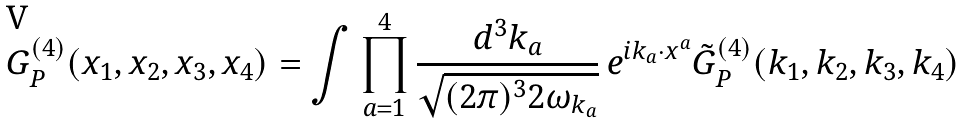<formula> <loc_0><loc_0><loc_500><loc_500>G ^ { ( 4 ) } _ { P } ( x _ { 1 } , x _ { 2 } , x _ { 3 } , x _ { 4 } ) = \int \prod _ { a = 1 } ^ { 4 } \frac { d ^ { 3 } k _ { a } } { \sqrt { ( 2 \pi ) ^ { 3 } 2 \omega _ { k _ { a } } } } \, e ^ { i k _ { a } \cdot x ^ { a } } \tilde { G } ^ { ( 4 ) } _ { P } ( k _ { 1 } , k _ { 2 } , k _ { 3 } , k _ { 4 } )</formula> 